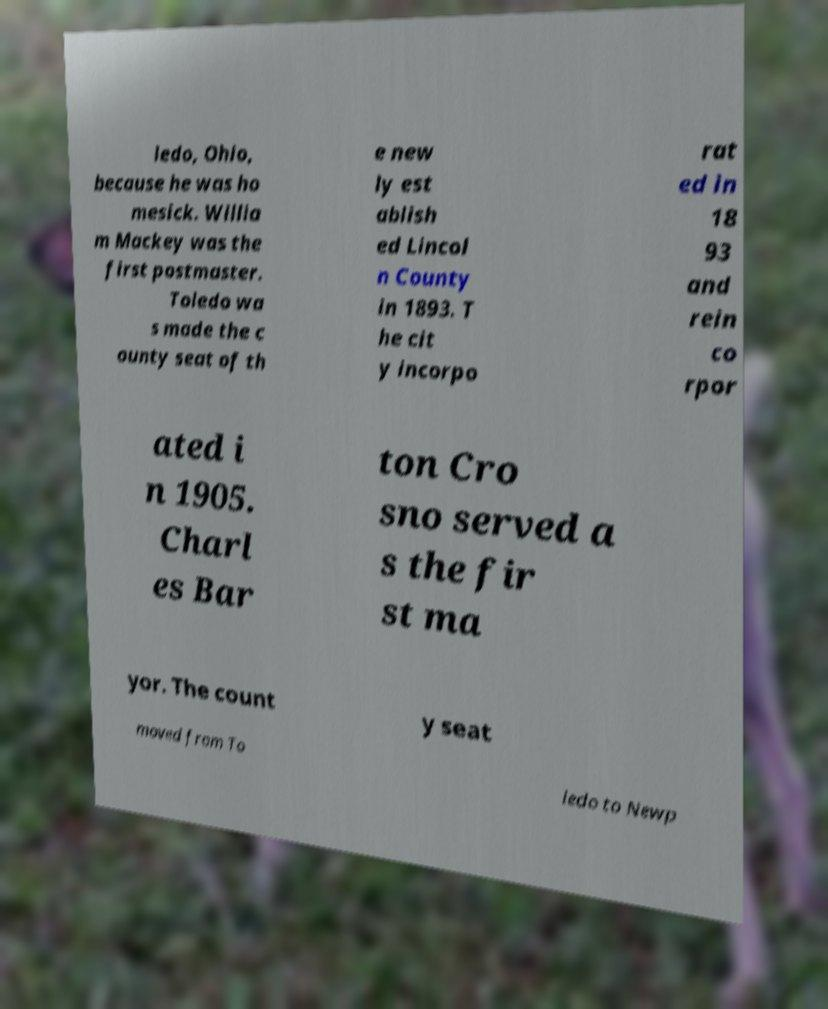Can you read and provide the text displayed in the image?This photo seems to have some interesting text. Can you extract and type it out for me? ledo, Ohio, because he was ho mesick. Willia m Mackey was the first postmaster. Toledo wa s made the c ounty seat of th e new ly est ablish ed Lincol n County in 1893. T he cit y incorpo rat ed in 18 93 and rein co rpor ated i n 1905. Charl es Bar ton Cro sno served a s the fir st ma yor. The count y seat moved from To ledo to Newp 